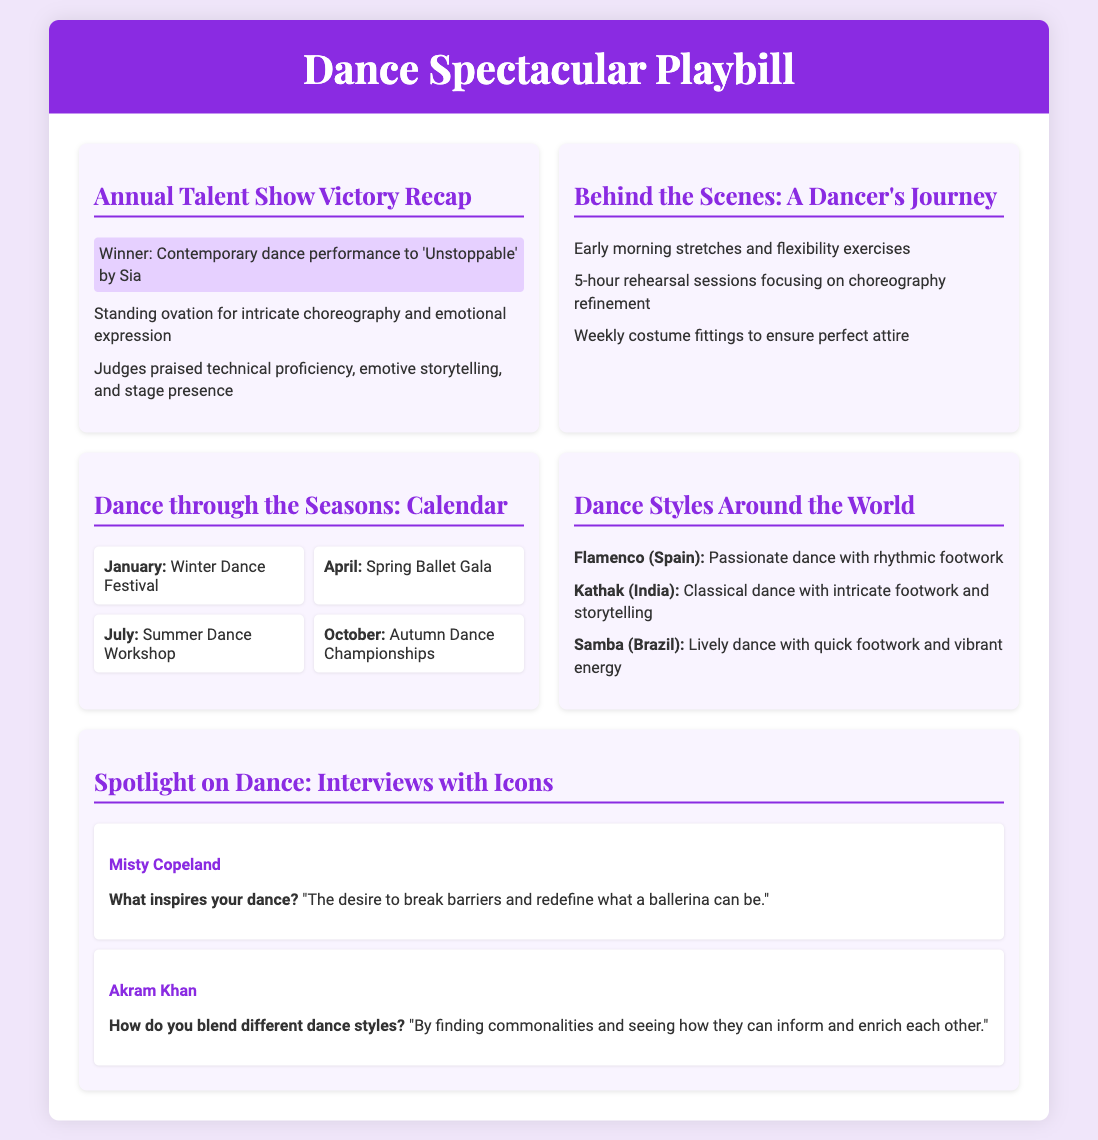What was the winning performance? The document indicates that the winning performance was a contemporary dance to 'Unstoppable' by Sia.
Answer: Contemporary dance performance to 'Unstoppable' by Sia What did the judges praise about the performance? The judges praised several aspects, including technical proficiency, emotive storytelling, and stage presence.
Answer: Technical proficiency, emotive storytelling, and stage presence How many rehearsal sessions were conducted weekly? The document mentions 5-hour rehearsal sessions focusing on choreography refinement, indicating a significant commitment.
Answer: 5-hour Which dance event occurs in April? The document lists the Spring Ballet Gala as the event happening in April.
Answer: Spring Ballet Gala What kind of dance is Flamenco? The document describes Flamenco as a passionate dance with rhythmic footwork.
Answer: Passionate dance with rhythmic footwork Who was interviewed in the Spotlight on Dance section? The document includes interviews with renowned dancers, specifically mentioning Misty Copeland and Akram Khan.
Answer: Misty Copeland and Akram Khan How many events are listed in the Dance through the Seasons section? The document details four events in the calendar: Winter Dance Festival, Spring Ballet Gala, Summer Dance Workshop, and Autumn Dance Championships.
Answer: 4 What is the primary focus of the Behind the Scenes section? This section presents the preparation routine of the dancer, including stretches, rehearsals, and costume fittings.
Answer: Preparation routine What color is the header background? The document specifies the header background color as #8a2be2.
Answer: #8a2be2 